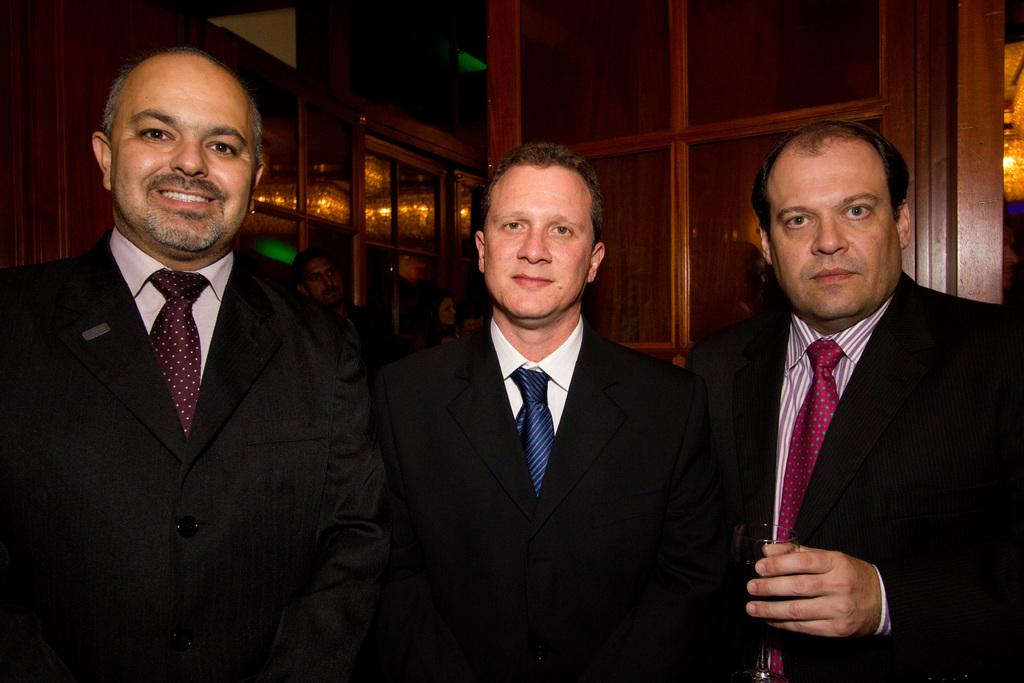How many people are present in the image? There are three people in the image. What is one person holding in the image? One person is holding a glass. Can you describe the background of the image? There are people and objects in the background of the image. What type of health benefits can be gained from the sun in the image? There is no sun present in the image, so it is not possible to discuss any health benefits related to it. 